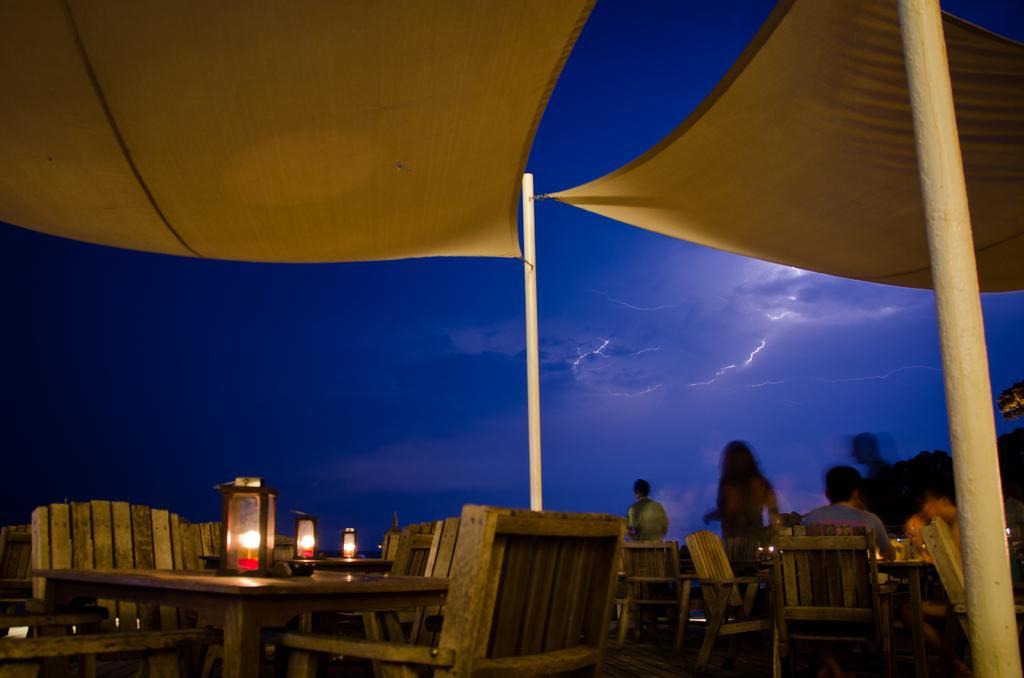Please provide a concise description of this image. In this image I can see few people are sitting on chairs. I can see few chairs, tables and few lanterns on tables. I can see the yellow cloth is attached to the poles. The sky is in blue and white color. 